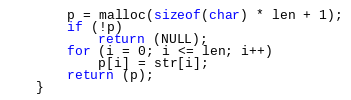Convert code to text. <code><loc_0><loc_0><loc_500><loc_500><_C_>	p = malloc(sizeof(char) * len + 1);
	if (!p)
		return (NULL);
	for (i = 0; i <= len; i++)
		p[i] = str[i];
	return (p);
}
</code> 